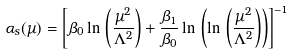<formula> <loc_0><loc_0><loc_500><loc_500>\alpha _ { s } ( \mu ) = \left [ \beta _ { 0 } \ln \, \left ( \frac { \mu ^ { 2 } } { \Lambda ^ { 2 } } \right ) + \frac { \beta _ { 1 } } { \beta _ { 0 } } \ln \, \left ( \ln \, \left ( \frac { \mu ^ { 2 } } { \Lambda ^ { 2 } } \right ) \right ) \right ] ^ { - 1 }</formula> 